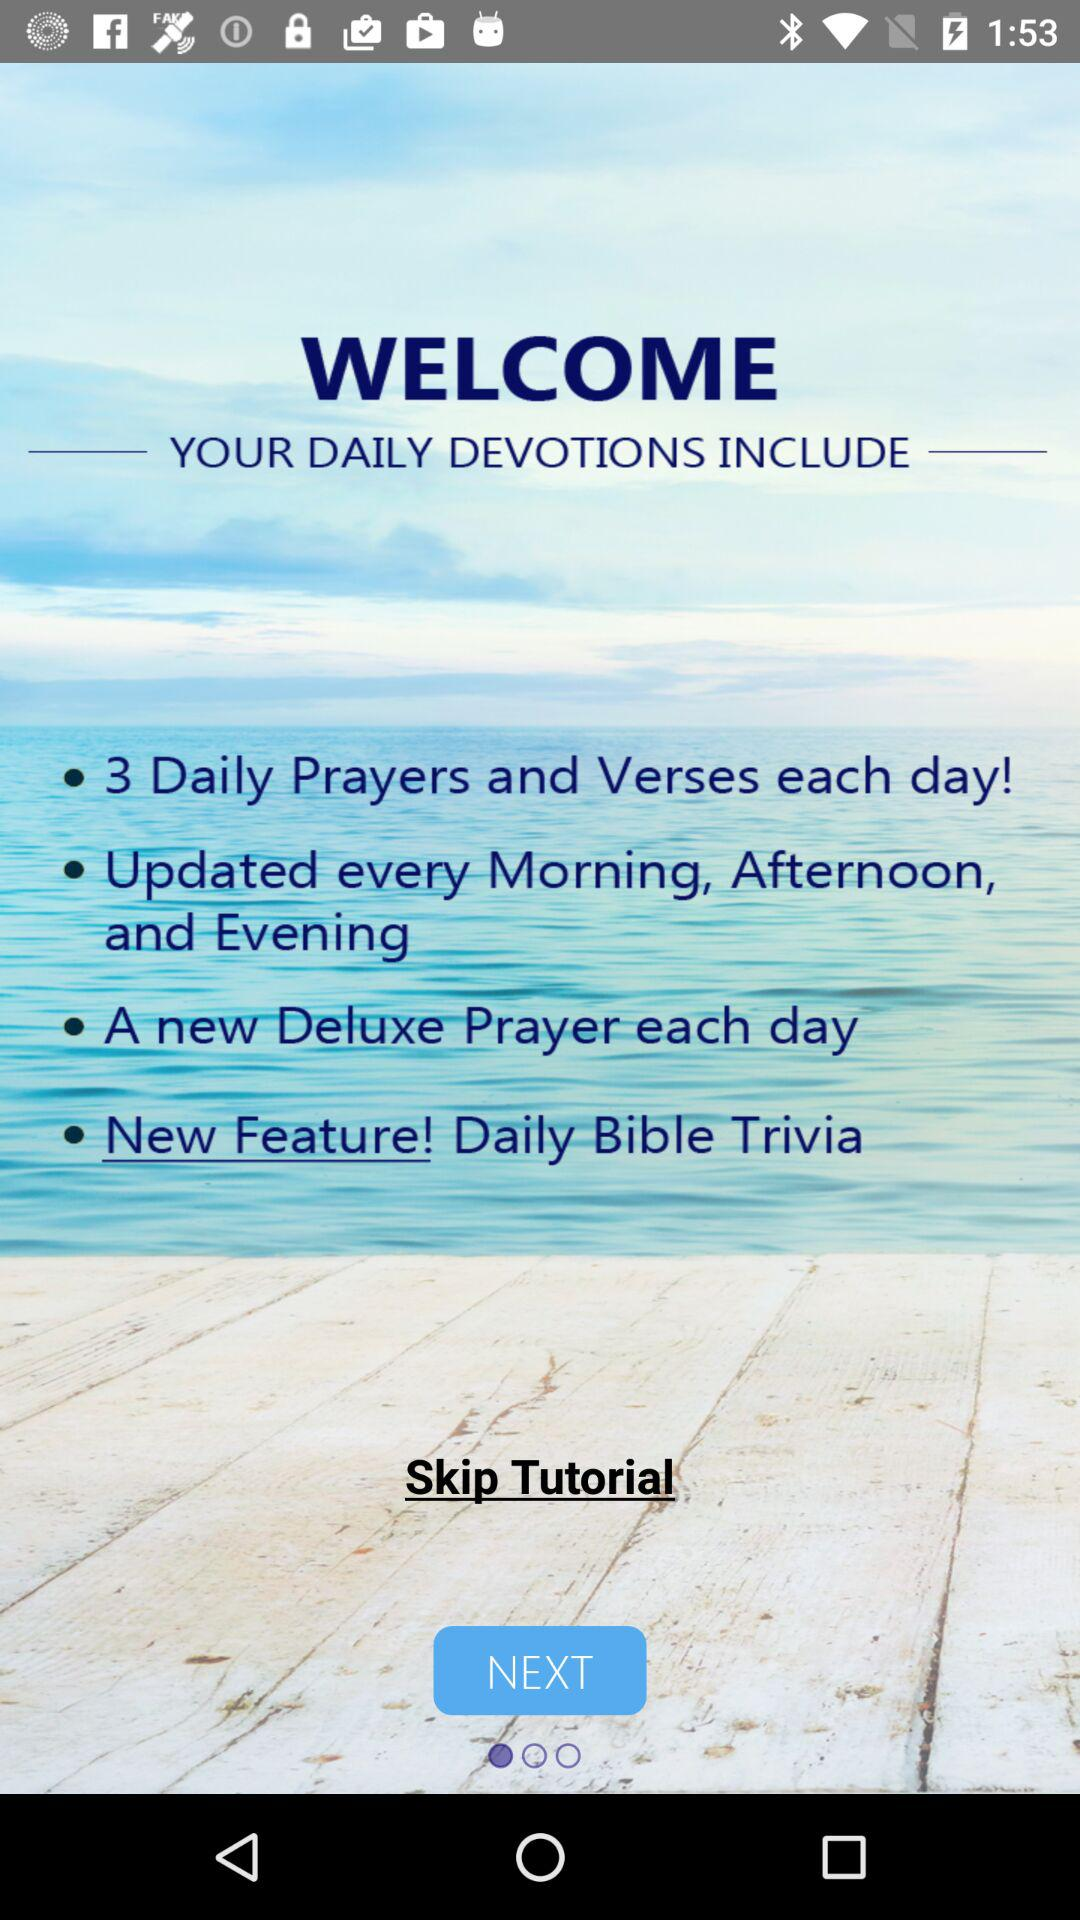What is the given count of daily prayers? The given count of daily prayers is 3. 